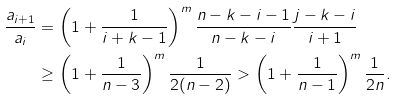<formula> <loc_0><loc_0><loc_500><loc_500>\frac { a _ { i + 1 } } { a _ { i } } & = \left ( 1 + \frac { 1 } { i + k - 1 } \right ) ^ { m } \frac { n - k - i - 1 } { n - k - i } \frac { j - k - i } { i + 1 } \\ & \geq \left ( 1 + \frac { 1 } { n - 3 } \right ) ^ { m } \frac { 1 } { 2 ( n - 2 ) } > \left ( 1 + \frac { 1 } { n - 1 } \right ) ^ { m } \frac { 1 } { 2 n } .</formula> 